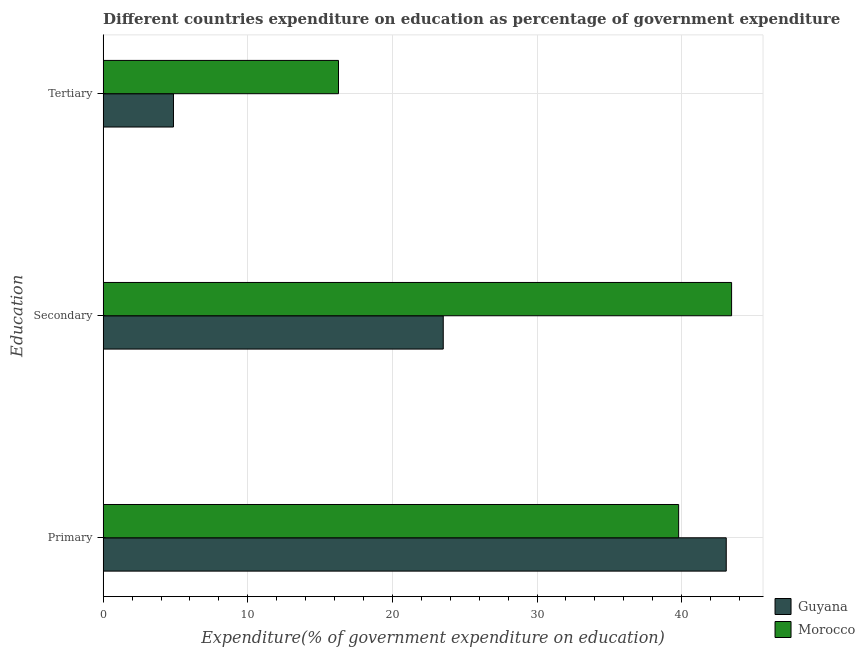How many different coloured bars are there?
Your answer should be very brief. 2. Are the number of bars per tick equal to the number of legend labels?
Provide a short and direct response. Yes. How many bars are there on the 1st tick from the top?
Provide a succinct answer. 2. What is the label of the 1st group of bars from the top?
Your answer should be compact. Tertiary. What is the expenditure on tertiary education in Guyana?
Offer a very short reply. 4.86. Across all countries, what is the maximum expenditure on secondary education?
Provide a succinct answer. 43.45. Across all countries, what is the minimum expenditure on secondary education?
Make the answer very short. 23.51. In which country was the expenditure on tertiary education maximum?
Keep it short and to the point. Morocco. In which country was the expenditure on tertiary education minimum?
Offer a terse response. Guyana. What is the total expenditure on secondary education in the graph?
Offer a terse response. 66.96. What is the difference between the expenditure on secondary education in Guyana and that in Morocco?
Offer a terse response. -19.94. What is the difference between the expenditure on primary education in Guyana and the expenditure on tertiary education in Morocco?
Give a very brief answer. 26.81. What is the average expenditure on tertiary education per country?
Give a very brief answer. 10.57. What is the difference between the expenditure on primary education and expenditure on secondary education in Morocco?
Offer a terse response. -3.66. In how many countries, is the expenditure on secondary education greater than 32 %?
Keep it short and to the point. 1. What is the ratio of the expenditure on secondary education in Morocco to that in Guyana?
Make the answer very short. 1.85. Is the expenditure on primary education in Guyana less than that in Morocco?
Give a very brief answer. No. Is the difference between the expenditure on secondary education in Guyana and Morocco greater than the difference between the expenditure on primary education in Guyana and Morocco?
Your answer should be compact. No. What is the difference between the highest and the second highest expenditure on tertiary education?
Your answer should be very brief. 11.41. What is the difference between the highest and the lowest expenditure on secondary education?
Provide a succinct answer. 19.94. In how many countries, is the expenditure on tertiary education greater than the average expenditure on tertiary education taken over all countries?
Keep it short and to the point. 1. What does the 1st bar from the top in Secondary represents?
Offer a very short reply. Morocco. What does the 1st bar from the bottom in Tertiary represents?
Your answer should be compact. Guyana. Is it the case that in every country, the sum of the expenditure on primary education and expenditure on secondary education is greater than the expenditure on tertiary education?
Your answer should be very brief. Yes. How many bars are there?
Your response must be concise. 6. Are all the bars in the graph horizontal?
Ensure brevity in your answer.  Yes. What is the difference between two consecutive major ticks on the X-axis?
Ensure brevity in your answer.  10. Are the values on the major ticks of X-axis written in scientific E-notation?
Your answer should be compact. No. Where does the legend appear in the graph?
Offer a very short reply. Bottom right. How many legend labels are there?
Ensure brevity in your answer.  2. How are the legend labels stacked?
Offer a very short reply. Vertical. What is the title of the graph?
Give a very brief answer. Different countries expenditure on education as percentage of government expenditure. Does "Bahamas" appear as one of the legend labels in the graph?
Your answer should be compact. No. What is the label or title of the X-axis?
Your response must be concise. Expenditure(% of government expenditure on education). What is the label or title of the Y-axis?
Your response must be concise. Education. What is the Expenditure(% of government expenditure on education) in Guyana in Primary?
Keep it short and to the point. 43.08. What is the Expenditure(% of government expenditure on education) in Morocco in Primary?
Provide a short and direct response. 39.79. What is the Expenditure(% of government expenditure on education) of Guyana in Secondary?
Your answer should be very brief. 23.51. What is the Expenditure(% of government expenditure on education) of Morocco in Secondary?
Keep it short and to the point. 43.45. What is the Expenditure(% of government expenditure on education) in Guyana in Tertiary?
Your answer should be very brief. 4.86. What is the Expenditure(% of government expenditure on education) in Morocco in Tertiary?
Offer a terse response. 16.27. Across all Education, what is the maximum Expenditure(% of government expenditure on education) in Guyana?
Provide a succinct answer. 43.08. Across all Education, what is the maximum Expenditure(% of government expenditure on education) in Morocco?
Offer a terse response. 43.45. Across all Education, what is the minimum Expenditure(% of government expenditure on education) in Guyana?
Give a very brief answer. 4.86. Across all Education, what is the minimum Expenditure(% of government expenditure on education) in Morocco?
Keep it short and to the point. 16.27. What is the total Expenditure(% of government expenditure on education) of Guyana in the graph?
Keep it short and to the point. 71.46. What is the total Expenditure(% of government expenditure on education) of Morocco in the graph?
Make the answer very short. 99.51. What is the difference between the Expenditure(% of government expenditure on education) of Guyana in Primary and that in Secondary?
Your answer should be very brief. 19.57. What is the difference between the Expenditure(% of government expenditure on education) of Morocco in Primary and that in Secondary?
Keep it short and to the point. -3.66. What is the difference between the Expenditure(% of government expenditure on education) of Guyana in Primary and that in Tertiary?
Make the answer very short. 38.22. What is the difference between the Expenditure(% of government expenditure on education) of Morocco in Primary and that in Tertiary?
Keep it short and to the point. 23.52. What is the difference between the Expenditure(% of government expenditure on education) in Guyana in Secondary and that in Tertiary?
Your response must be concise. 18.65. What is the difference between the Expenditure(% of government expenditure on education) in Morocco in Secondary and that in Tertiary?
Give a very brief answer. 27.18. What is the difference between the Expenditure(% of government expenditure on education) in Guyana in Primary and the Expenditure(% of government expenditure on education) in Morocco in Secondary?
Provide a succinct answer. -0.37. What is the difference between the Expenditure(% of government expenditure on education) in Guyana in Primary and the Expenditure(% of government expenditure on education) in Morocco in Tertiary?
Provide a short and direct response. 26.81. What is the difference between the Expenditure(% of government expenditure on education) of Guyana in Secondary and the Expenditure(% of government expenditure on education) of Morocco in Tertiary?
Your answer should be compact. 7.24. What is the average Expenditure(% of government expenditure on education) in Guyana per Education?
Keep it short and to the point. 23.82. What is the average Expenditure(% of government expenditure on education) of Morocco per Education?
Your answer should be compact. 33.17. What is the difference between the Expenditure(% of government expenditure on education) in Guyana and Expenditure(% of government expenditure on education) in Morocco in Primary?
Your response must be concise. 3.29. What is the difference between the Expenditure(% of government expenditure on education) of Guyana and Expenditure(% of government expenditure on education) of Morocco in Secondary?
Your answer should be compact. -19.94. What is the difference between the Expenditure(% of government expenditure on education) in Guyana and Expenditure(% of government expenditure on education) in Morocco in Tertiary?
Your response must be concise. -11.41. What is the ratio of the Expenditure(% of government expenditure on education) in Guyana in Primary to that in Secondary?
Provide a short and direct response. 1.83. What is the ratio of the Expenditure(% of government expenditure on education) of Morocco in Primary to that in Secondary?
Give a very brief answer. 0.92. What is the ratio of the Expenditure(% of government expenditure on education) in Guyana in Primary to that in Tertiary?
Offer a terse response. 8.86. What is the ratio of the Expenditure(% of government expenditure on education) of Morocco in Primary to that in Tertiary?
Your answer should be very brief. 2.45. What is the ratio of the Expenditure(% of government expenditure on education) in Guyana in Secondary to that in Tertiary?
Your response must be concise. 4.84. What is the ratio of the Expenditure(% of government expenditure on education) of Morocco in Secondary to that in Tertiary?
Ensure brevity in your answer.  2.67. What is the difference between the highest and the second highest Expenditure(% of government expenditure on education) of Guyana?
Make the answer very short. 19.57. What is the difference between the highest and the second highest Expenditure(% of government expenditure on education) of Morocco?
Your answer should be very brief. 3.66. What is the difference between the highest and the lowest Expenditure(% of government expenditure on education) of Guyana?
Keep it short and to the point. 38.22. What is the difference between the highest and the lowest Expenditure(% of government expenditure on education) in Morocco?
Keep it short and to the point. 27.18. 